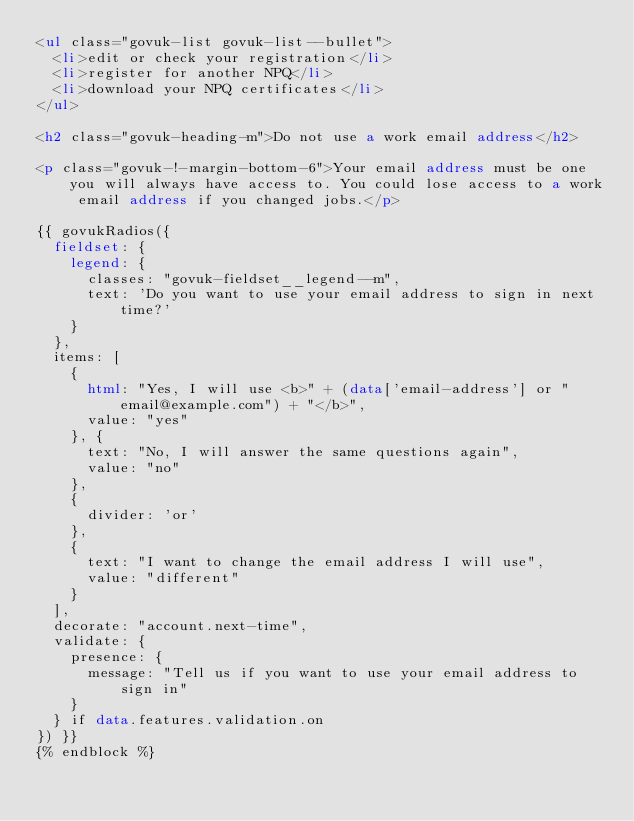<code> <loc_0><loc_0><loc_500><loc_500><_HTML_><ul class="govuk-list govuk-list--bullet">
  <li>edit or check your registration</li>
  <li>register for another NPQ</li>
  <li>download your NPQ certificates</li>
</ul>

<h2 class="govuk-heading-m">Do not use a work email address</h2>

<p class="govuk-!-margin-bottom-6">Your email address must be one you will always have access to. You could lose access to a work email address if you changed jobs.</p>

{{ govukRadios({
  fieldset: {
    legend: {
      classes: "govuk-fieldset__legend--m",
      text: 'Do you want to use your email address to sign in next time?'
    }
  },
  items: [
    {
      html: "Yes, I will use <b>" + (data['email-address'] or "email@example.com") + "</b>",
      value: "yes"
    }, {
      text: "No, I will answer the same questions again",
      value: "no"
    },
    {
      divider: 'or'
    },
    {
      text: "I want to change the email address I will use",
      value: "different"
    }
  ],
  decorate: "account.next-time",
  validate: {
    presence: {
      message: "Tell us if you want to use your email address to sign in"
    }
  } if data.features.validation.on
}) }}
{% endblock %}
</code> 